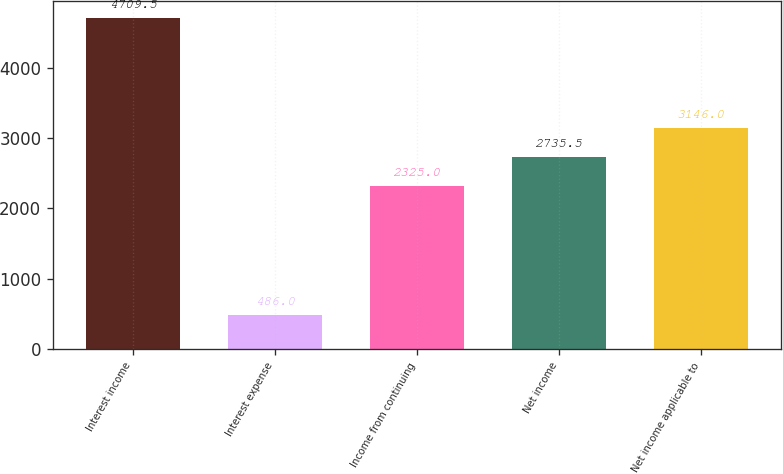<chart> <loc_0><loc_0><loc_500><loc_500><bar_chart><fcel>Interest income<fcel>Interest expense<fcel>Income from continuing<fcel>Net income<fcel>Net income applicable to<nl><fcel>4709.5<fcel>486<fcel>2325<fcel>2735.5<fcel>3146<nl></chart> 